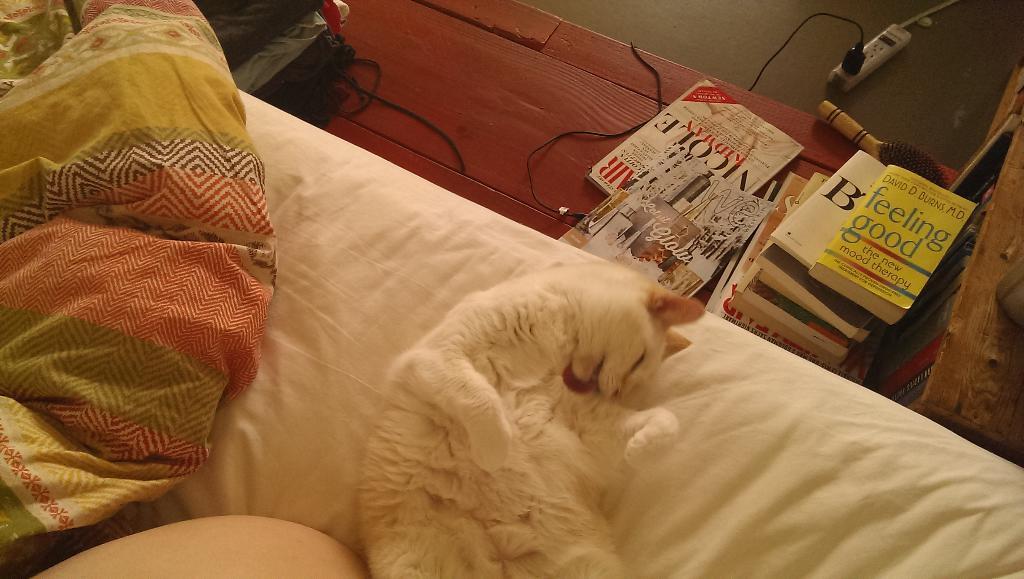Can you describe this image briefly? There is a white color cat, laying on white color sofa, on which, there is a cloth, near books arranged on a shelf and near a cupboard which is having a shelf, on which, there are books arranged. In the background, there is a plug board on the floor and there is a cable. 